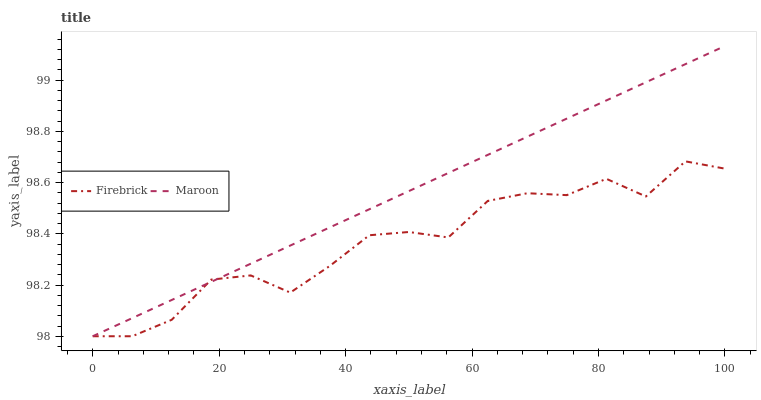Does Maroon have the minimum area under the curve?
Answer yes or no. No. Is Maroon the roughest?
Answer yes or no. No. 